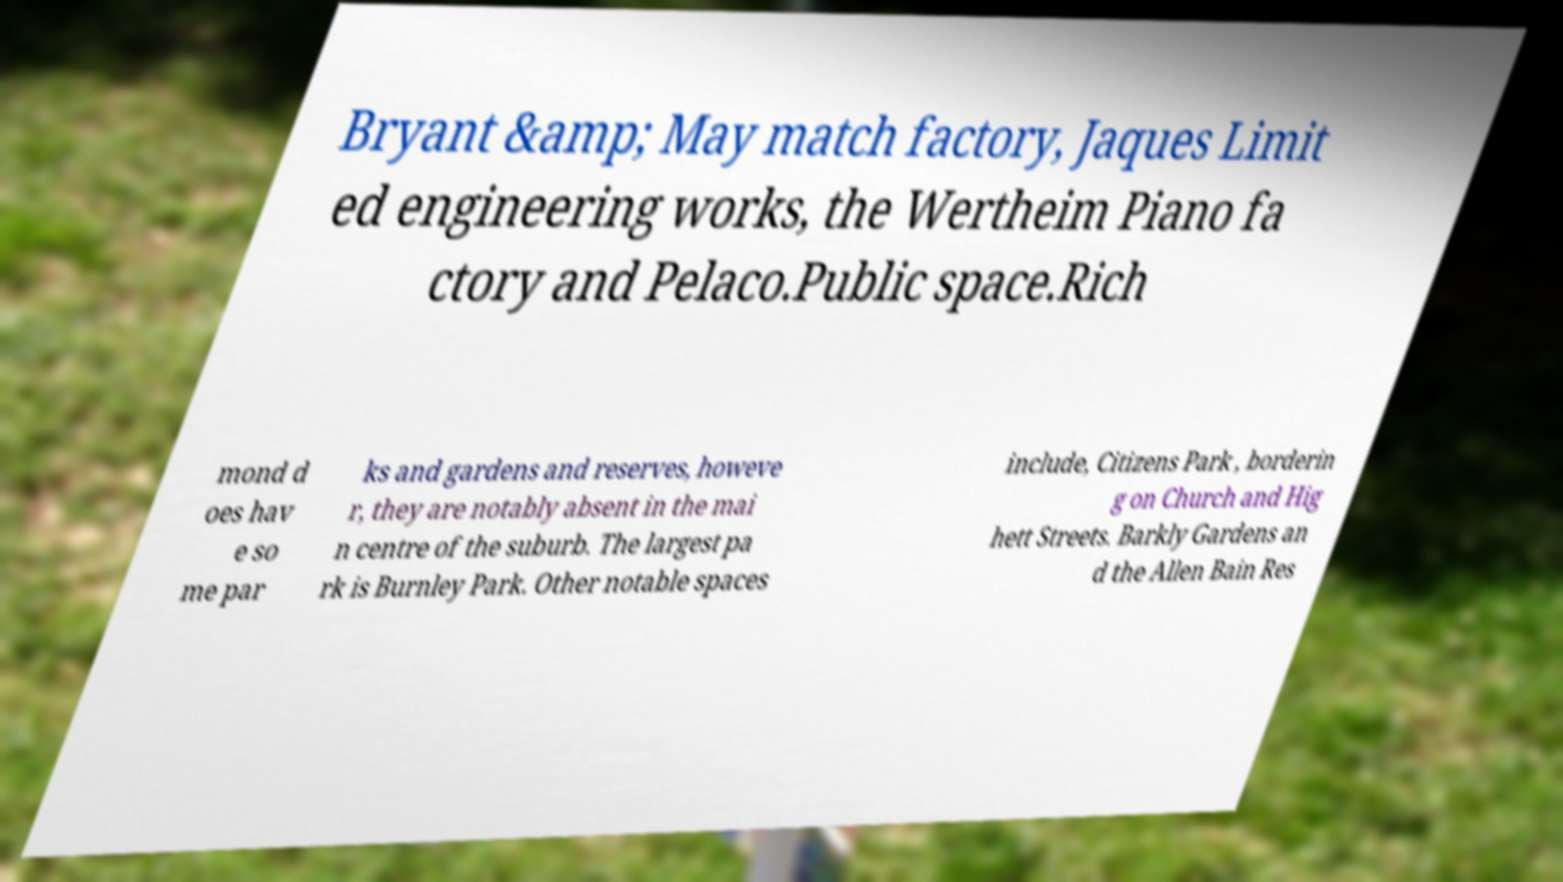Please read and relay the text visible in this image. What does it say? Bryant &amp; May match factory, Jaques Limit ed engineering works, the Wertheim Piano fa ctory and Pelaco.Public space.Rich mond d oes hav e so me par ks and gardens and reserves, howeve r, they are notably absent in the mai n centre of the suburb. The largest pa rk is Burnley Park. Other notable spaces include, Citizens Park , borderin g on Church and Hig hett Streets. Barkly Gardens an d the Allen Bain Res 